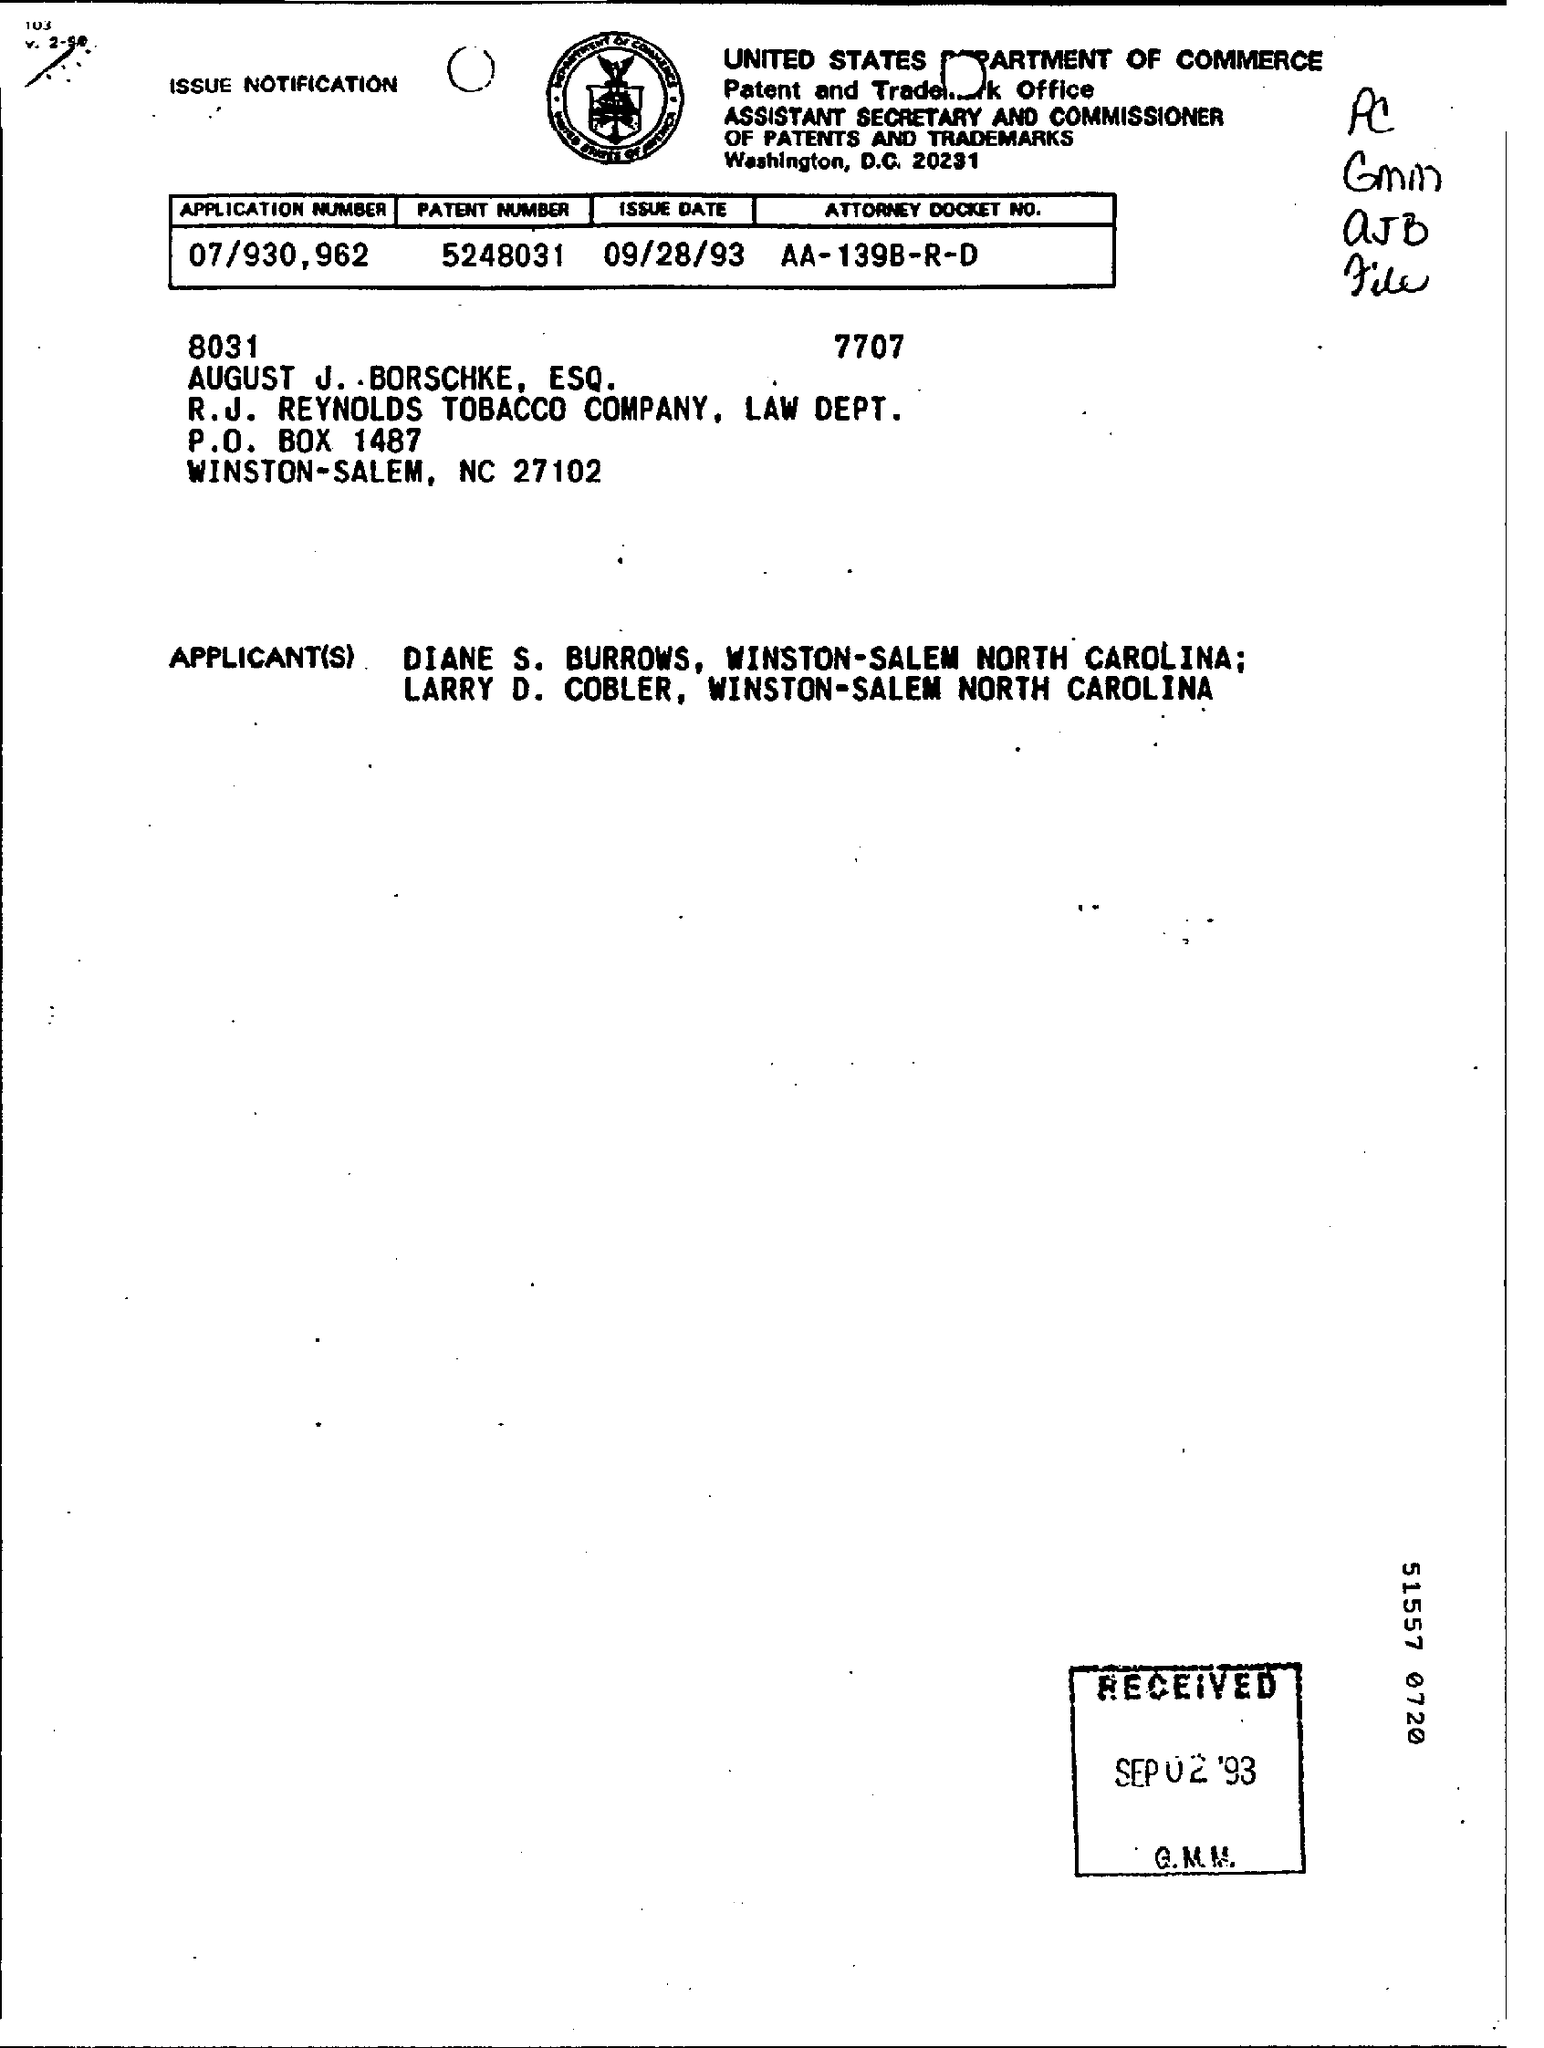What is the Application Number?
Provide a succinct answer. 07/930,962. What is the Patent Number?
Your answer should be compact. 5248031. What is the Issue Date?
Provide a succinct answer. 09/28/93. 